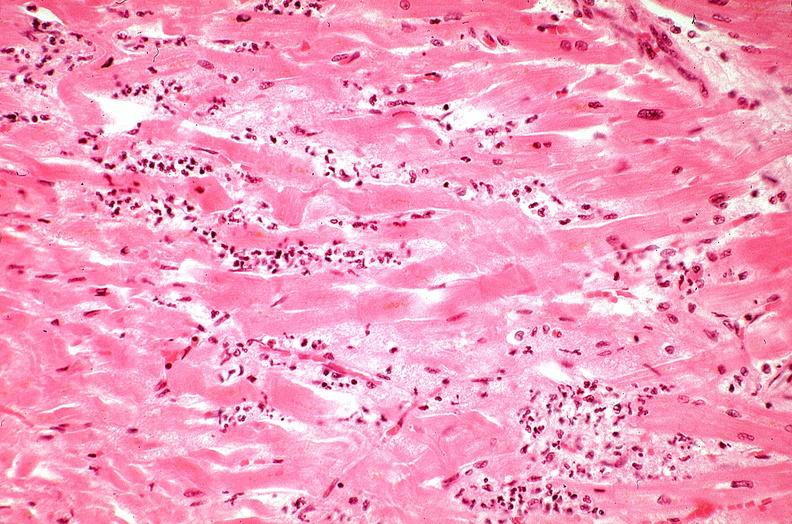s cardiovascular present?
Answer the question using a single word or phrase. Yes 